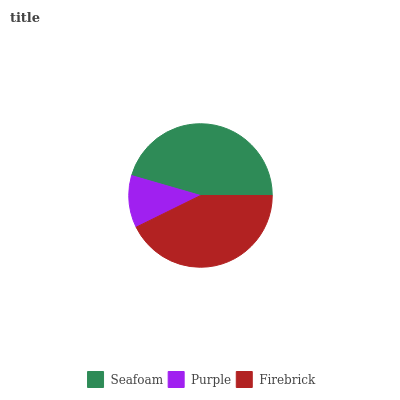Is Purple the minimum?
Answer yes or no. Yes. Is Seafoam the maximum?
Answer yes or no. Yes. Is Firebrick the minimum?
Answer yes or no. No. Is Firebrick the maximum?
Answer yes or no. No. Is Firebrick greater than Purple?
Answer yes or no. Yes. Is Purple less than Firebrick?
Answer yes or no. Yes. Is Purple greater than Firebrick?
Answer yes or no. No. Is Firebrick less than Purple?
Answer yes or no. No. Is Firebrick the high median?
Answer yes or no. Yes. Is Firebrick the low median?
Answer yes or no. Yes. Is Purple the high median?
Answer yes or no. No. Is Seafoam the low median?
Answer yes or no. No. 